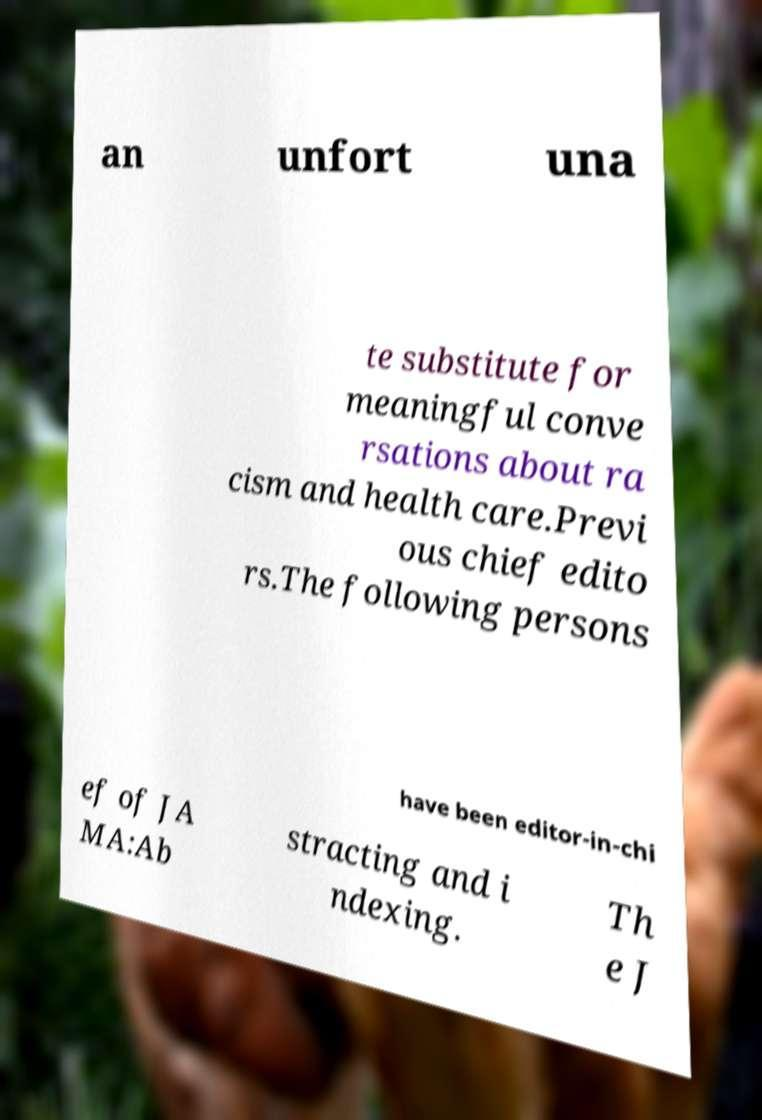Could you assist in decoding the text presented in this image and type it out clearly? an unfort una te substitute for meaningful conve rsations about ra cism and health care.Previ ous chief edito rs.The following persons have been editor-in-chi ef of JA MA:Ab stracting and i ndexing. Th e J 